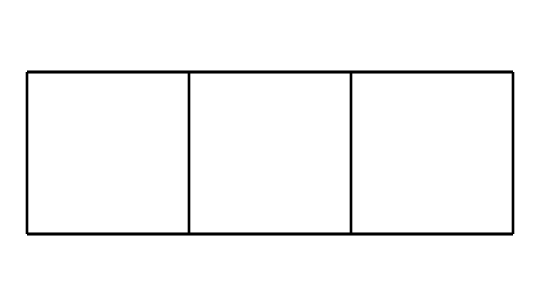What is the molecular formula of cubane? Based on the structure, cubane contains 8 carbon atoms (C) and 8 hydrogen atoms (H). The molecular formula is derived by counting the number of carbon and hydrogen atoms present in the chemical structure.
Answer: C8H8 How many carbon atoms are present in cubane? By analyzing the chemical structure visually or through the SMILES representation, we can count that there are 8 carbon atoms included in cubane.
Answer: 8 What type of hybridization do the carbon atoms in cubane exhibit? The carbon atoms in cubane form four single bonds with other atoms, suggesting that they are sp3 hybridized. This is typical for alkanes with tetrahedral geometry.
Answer: sp3 Why is cubane considered a highly strained compound? The angles between the carbon-carbon bonds in cubane deviate from the ideal tetrahedral angle of 109.5 degrees, creating significant angle strain. This strain arises from the cubical arrangement of the carbon atoms.
Answer: angle strain What are potential applications of cubane? Due to its high energy density and stability when burned, cubane is explored for use in high-energy fuels and explosives, owing to its unique structural properties.
Answer: high-energy fuels How many hydrogen atoms are attached to each carbon atom in cubane? Each carbon atom in cubane is connected to two hydrogen atoms, as evident from the structure where carbon bonds saturate with hydrogen.
Answer: 2 What type of compound is cubane categorized as? Cubane belongs to the category of cage compounds, characterized by their unique geometric structures forming a three-dimensional shape containing multiple carbon atoms.
Answer: cage compound 